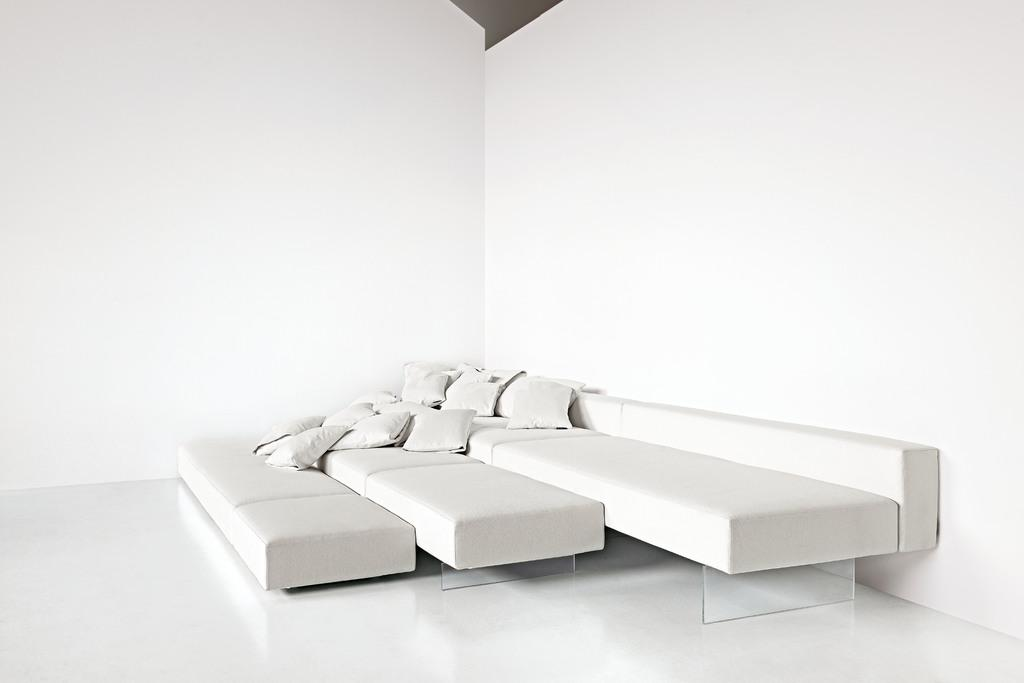What type of furniture is present in the image? There is a sofa in the image. What additional features can be seen on the sofa? There are cushions on the sofa. What type of disgusting office equipment can be seen on the sofa? There is no office equipment or any indication of disgust in the image; it only features a sofa with cushions. 